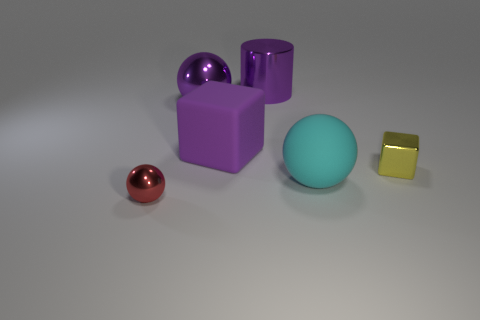Subtract all metallic balls. How many balls are left? 1 Add 2 tiny balls. How many objects exist? 8 Subtract all cubes. How many objects are left? 4 Add 4 tiny yellow metal blocks. How many tiny yellow metal blocks exist? 5 Subtract 0 gray cylinders. How many objects are left? 6 Subtract all tiny brown shiny cylinders. Subtract all big cylinders. How many objects are left? 5 Add 2 matte spheres. How many matte spheres are left? 3 